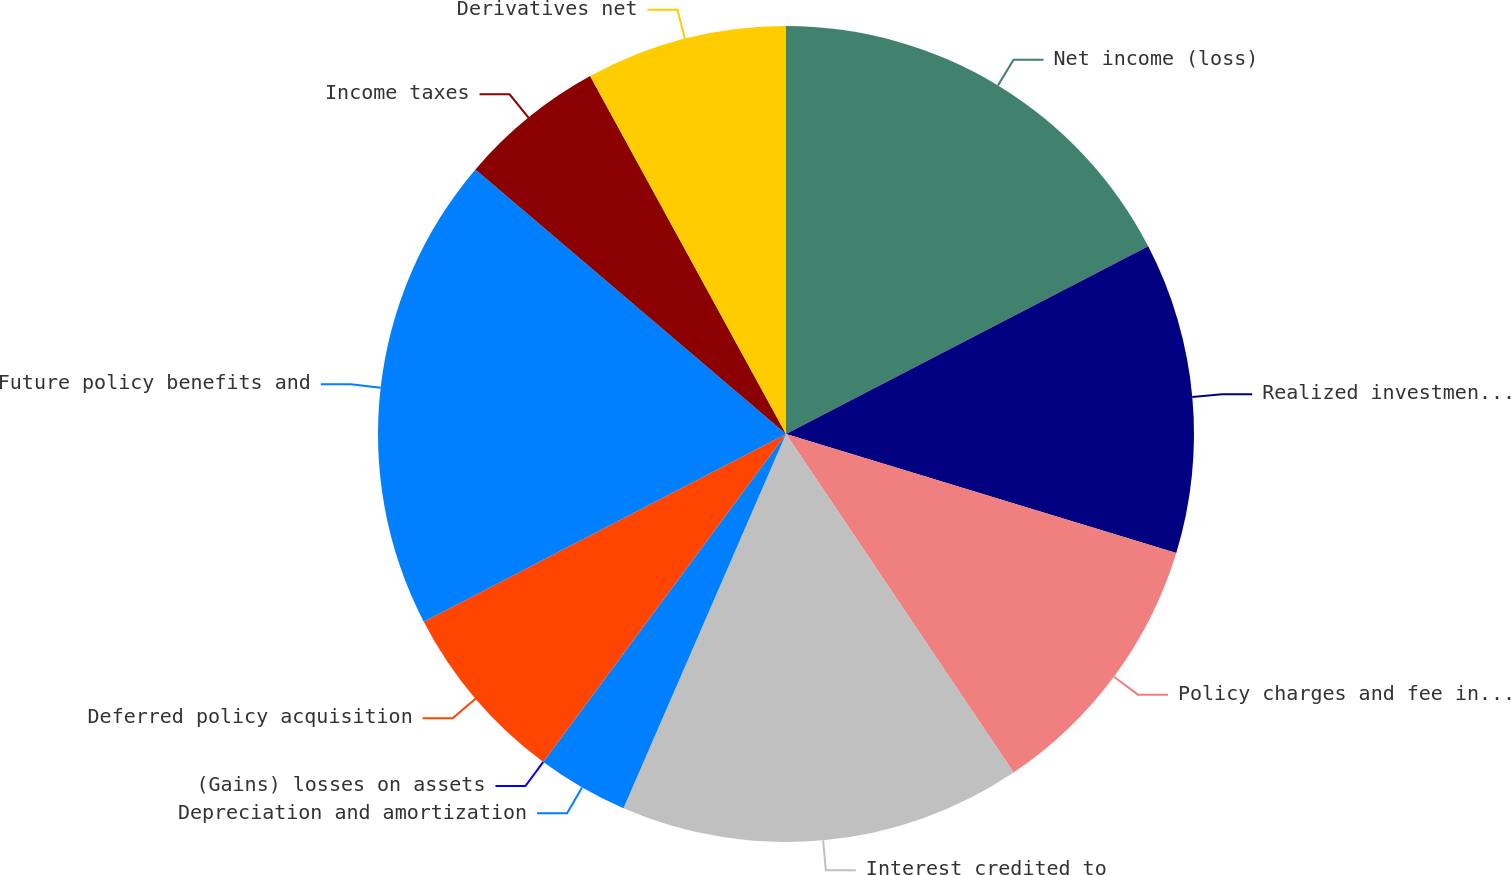<chart> <loc_0><loc_0><loc_500><loc_500><pie_chart><fcel>Net income (loss)<fcel>Realized investment (gains)<fcel>Policy charges and fee income<fcel>Interest credited to<fcel>Depreciation and amortization<fcel>(Gains) losses on assets<fcel>Deferred policy acquisition<fcel>Future policy benefits and<fcel>Income taxes<fcel>Derivatives net<nl><fcel>17.39%<fcel>12.32%<fcel>10.87%<fcel>15.94%<fcel>3.62%<fcel>0.0%<fcel>7.25%<fcel>18.84%<fcel>5.8%<fcel>7.97%<nl></chart> 